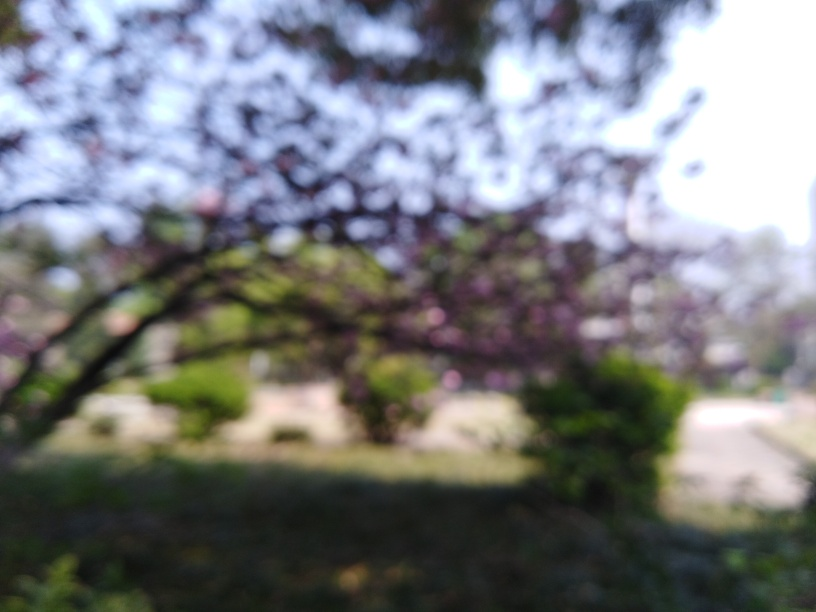What time of day does this setting appear to depict, and why is the image blurred? The soft lighting and muted colors suggest it could be either dawn or dusk, times when the light is more diffused. The image appears blurred due to a shallow depth of field or potential camera movement, preventing the fine details from being in focus. 